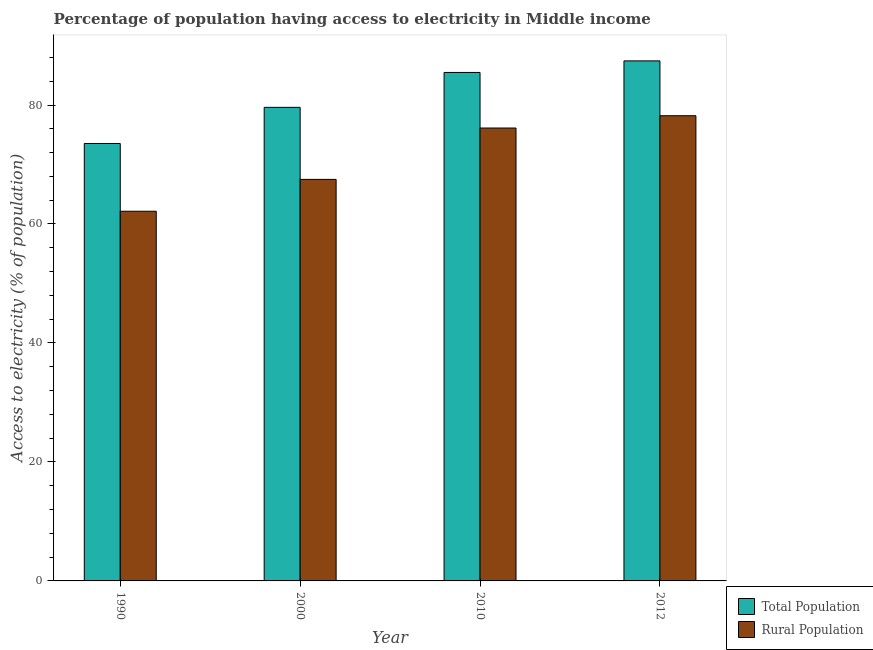How many groups of bars are there?
Your response must be concise. 4. Are the number of bars per tick equal to the number of legend labels?
Give a very brief answer. Yes. Are the number of bars on each tick of the X-axis equal?
Ensure brevity in your answer.  Yes. How many bars are there on the 3rd tick from the right?
Provide a short and direct response. 2. What is the percentage of rural population having access to electricity in 2000?
Your answer should be compact. 67.5. Across all years, what is the maximum percentage of rural population having access to electricity?
Give a very brief answer. 78.2. Across all years, what is the minimum percentage of rural population having access to electricity?
Give a very brief answer. 62.14. In which year was the percentage of population having access to electricity maximum?
Ensure brevity in your answer.  2012. What is the total percentage of population having access to electricity in the graph?
Provide a short and direct response. 326.03. What is the difference between the percentage of rural population having access to electricity in 2010 and that in 2012?
Offer a terse response. -2.07. What is the difference between the percentage of rural population having access to electricity in 1990 and the percentage of population having access to electricity in 2000?
Keep it short and to the point. -5.36. What is the average percentage of population having access to electricity per year?
Your answer should be compact. 81.51. What is the ratio of the percentage of population having access to electricity in 1990 to that in 2000?
Your response must be concise. 0.92. Is the percentage of rural population having access to electricity in 1990 less than that in 2012?
Offer a terse response. Yes. What is the difference between the highest and the second highest percentage of population having access to electricity?
Ensure brevity in your answer.  1.94. What is the difference between the highest and the lowest percentage of population having access to electricity?
Provide a succinct answer. 13.89. Is the sum of the percentage of population having access to electricity in 2010 and 2012 greater than the maximum percentage of rural population having access to electricity across all years?
Keep it short and to the point. Yes. What does the 2nd bar from the left in 2010 represents?
Make the answer very short. Rural Population. What does the 2nd bar from the right in 2010 represents?
Your answer should be very brief. Total Population. How many bars are there?
Your answer should be very brief. 8. Are all the bars in the graph horizontal?
Offer a very short reply. No. Does the graph contain any zero values?
Keep it short and to the point. No. Does the graph contain grids?
Provide a short and direct response. No. Where does the legend appear in the graph?
Your answer should be compact. Bottom right. What is the title of the graph?
Give a very brief answer. Percentage of population having access to electricity in Middle income. Does "Females" appear as one of the legend labels in the graph?
Provide a succinct answer. No. What is the label or title of the X-axis?
Offer a terse response. Year. What is the label or title of the Y-axis?
Give a very brief answer. Access to electricity (% of population). What is the Access to electricity (% of population) of Total Population in 1990?
Your answer should be very brief. 73.53. What is the Access to electricity (% of population) of Rural Population in 1990?
Make the answer very short. 62.14. What is the Access to electricity (% of population) in Total Population in 2000?
Keep it short and to the point. 79.61. What is the Access to electricity (% of population) of Rural Population in 2000?
Make the answer very short. 67.5. What is the Access to electricity (% of population) in Total Population in 2010?
Your answer should be very brief. 85.47. What is the Access to electricity (% of population) in Rural Population in 2010?
Provide a succinct answer. 76.13. What is the Access to electricity (% of population) in Total Population in 2012?
Provide a short and direct response. 87.42. What is the Access to electricity (% of population) in Rural Population in 2012?
Offer a terse response. 78.2. Across all years, what is the maximum Access to electricity (% of population) of Total Population?
Your response must be concise. 87.42. Across all years, what is the maximum Access to electricity (% of population) in Rural Population?
Provide a succinct answer. 78.2. Across all years, what is the minimum Access to electricity (% of population) of Total Population?
Ensure brevity in your answer.  73.53. Across all years, what is the minimum Access to electricity (% of population) of Rural Population?
Offer a very short reply. 62.14. What is the total Access to electricity (% of population) in Total Population in the graph?
Your answer should be compact. 326.03. What is the total Access to electricity (% of population) of Rural Population in the graph?
Your answer should be compact. 283.97. What is the difference between the Access to electricity (% of population) in Total Population in 1990 and that in 2000?
Give a very brief answer. -6.08. What is the difference between the Access to electricity (% of population) of Rural Population in 1990 and that in 2000?
Offer a very short reply. -5.36. What is the difference between the Access to electricity (% of population) in Total Population in 1990 and that in 2010?
Provide a succinct answer. -11.94. What is the difference between the Access to electricity (% of population) in Rural Population in 1990 and that in 2010?
Provide a short and direct response. -13.99. What is the difference between the Access to electricity (% of population) of Total Population in 1990 and that in 2012?
Provide a short and direct response. -13.89. What is the difference between the Access to electricity (% of population) in Rural Population in 1990 and that in 2012?
Give a very brief answer. -16.06. What is the difference between the Access to electricity (% of population) of Total Population in 2000 and that in 2010?
Your answer should be compact. -5.87. What is the difference between the Access to electricity (% of population) of Rural Population in 2000 and that in 2010?
Give a very brief answer. -8.63. What is the difference between the Access to electricity (% of population) in Total Population in 2000 and that in 2012?
Provide a short and direct response. -7.81. What is the difference between the Access to electricity (% of population) of Rural Population in 2000 and that in 2012?
Your answer should be very brief. -10.7. What is the difference between the Access to electricity (% of population) of Total Population in 2010 and that in 2012?
Make the answer very short. -1.94. What is the difference between the Access to electricity (% of population) in Rural Population in 2010 and that in 2012?
Offer a very short reply. -2.07. What is the difference between the Access to electricity (% of population) in Total Population in 1990 and the Access to electricity (% of population) in Rural Population in 2000?
Offer a very short reply. 6.04. What is the difference between the Access to electricity (% of population) in Total Population in 1990 and the Access to electricity (% of population) in Rural Population in 2010?
Your answer should be compact. -2.6. What is the difference between the Access to electricity (% of population) in Total Population in 1990 and the Access to electricity (% of population) in Rural Population in 2012?
Give a very brief answer. -4.67. What is the difference between the Access to electricity (% of population) of Total Population in 2000 and the Access to electricity (% of population) of Rural Population in 2010?
Give a very brief answer. 3.48. What is the difference between the Access to electricity (% of population) of Total Population in 2000 and the Access to electricity (% of population) of Rural Population in 2012?
Make the answer very short. 1.41. What is the difference between the Access to electricity (% of population) of Total Population in 2010 and the Access to electricity (% of population) of Rural Population in 2012?
Offer a very short reply. 7.28. What is the average Access to electricity (% of population) of Total Population per year?
Ensure brevity in your answer.  81.51. What is the average Access to electricity (% of population) of Rural Population per year?
Make the answer very short. 70.99. In the year 1990, what is the difference between the Access to electricity (% of population) of Total Population and Access to electricity (% of population) of Rural Population?
Ensure brevity in your answer.  11.39. In the year 2000, what is the difference between the Access to electricity (% of population) in Total Population and Access to electricity (% of population) in Rural Population?
Ensure brevity in your answer.  12.11. In the year 2010, what is the difference between the Access to electricity (% of population) of Total Population and Access to electricity (% of population) of Rural Population?
Provide a succinct answer. 9.34. In the year 2012, what is the difference between the Access to electricity (% of population) in Total Population and Access to electricity (% of population) in Rural Population?
Offer a terse response. 9.22. What is the ratio of the Access to electricity (% of population) of Total Population in 1990 to that in 2000?
Your response must be concise. 0.92. What is the ratio of the Access to electricity (% of population) in Rural Population in 1990 to that in 2000?
Provide a short and direct response. 0.92. What is the ratio of the Access to electricity (% of population) in Total Population in 1990 to that in 2010?
Your answer should be compact. 0.86. What is the ratio of the Access to electricity (% of population) in Rural Population in 1990 to that in 2010?
Offer a terse response. 0.82. What is the ratio of the Access to electricity (% of population) of Total Population in 1990 to that in 2012?
Make the answer very short. 0.84. What is the ratio of the Access to electricity (% of population) in Rural Population in 1990 to that in 2012?
Your answer should be compact. 0.79. What is the ratio of the Access to electricity (% of population) in Total Population in 2000 to that in 2010?
Your answer should be very brief. 0.93. What is the ratio of the Access to electricity (% of population) of Rural Population in 2000 to that in 2010?
Give a very brief answer. 0.89. What is the ratio of the Access to electricity (% of population) in Total Population in 2000 to that in 2012?
Your answer should be compact. 0.91. What is the ratio of the Access to electricity (% of population) in Rural Population in 2000 to that in 2012?
Keep it short and to the point. 0.86. What is the ratio of the Access to electricity (% of population) in Total Population in 2010 to that in 2012?
Your answer should be compact. 0.98. What is the ratio of the Access to electricity (% of population) of Rural Population in 2010 to that in 2012?
Provide a succinct answer. 0.97. What is the difference between the highest and the second highest Access to electricity (% of population) in Total Population?
Offer a terse response. 1.94. What is the difference between the highest and the second highest Access to electricity (% of population) in Rural Population?
Offer a terse response. 2.07. What is the difference between the highest and the lowest Access to electricity (% of population) in Total Population?
Ensure brevity in your answer.  13.89. What is the difference between the highest and the lowest Access to electricity (% of population) in Rural Population?
Offer a terse response. 16.06. 